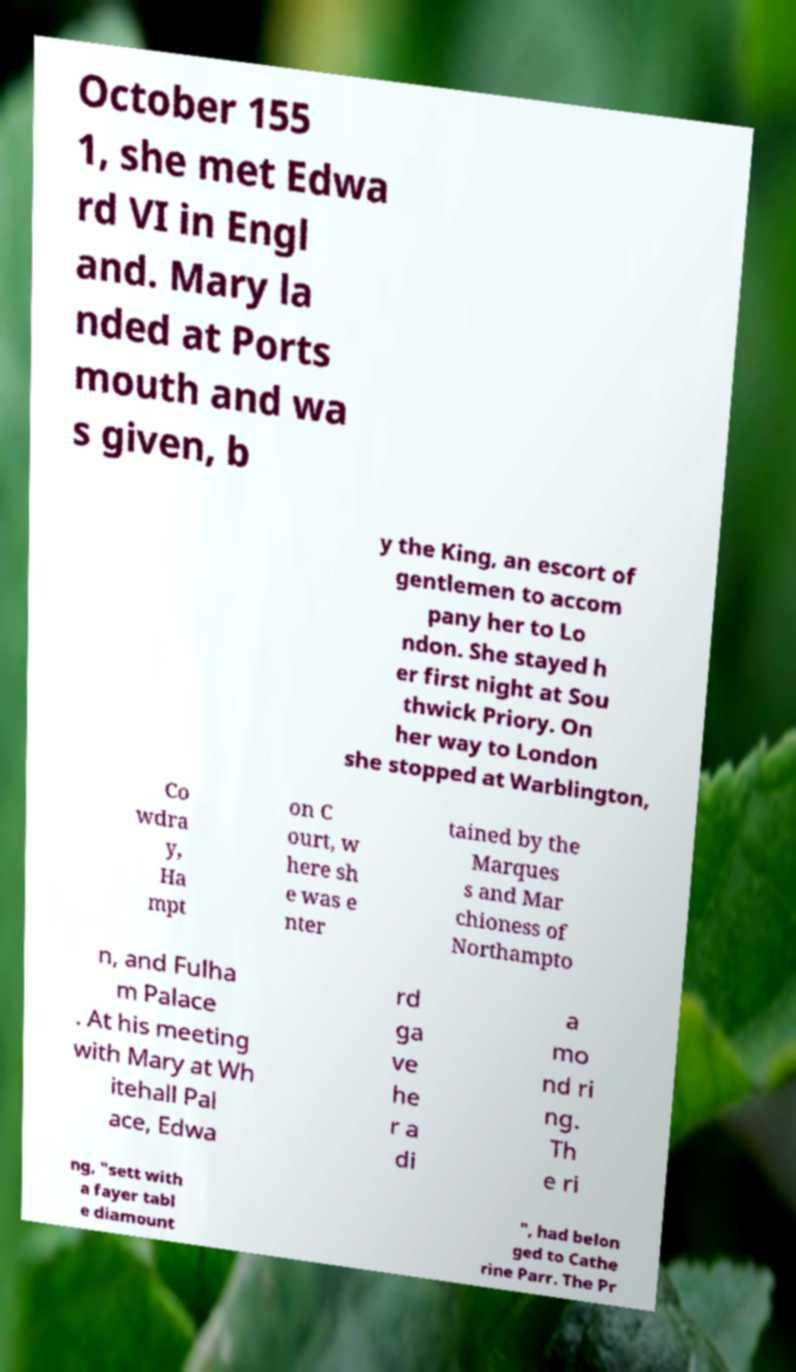For documentation purposes, I need the text within this image transcribed. Could you provide that? October 155 1, she met Edwa rd VI in Engl and. Mary la nded at Ports mouth and wa s given, b y the King, an escort of gentlemen to accom pany her to Lo ndon. She stayed h er first night at Sou thwick Priory. On her way to London she stopped at Warblington, Co wdra y, Ha mpt on C ourt, w here sh e was e nter tained by the Marques s and Mar chioness of Northampto n, and Fulha m Palace . At his meeting with Mary at Wh itehall Pal ace, Edwa rd ga ve he r a di a mo nd ri ng. Th e ri ng, "sett with a fayer tabl e diamount ", had belon ged to Cathe rine Parr. The Pr 